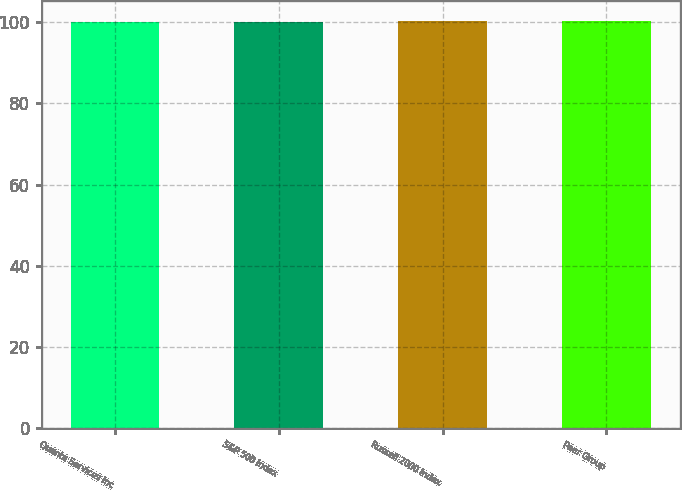Convert chart. <chart><loc_0><loc_0><loc_500><loc_500><bar_chart><fcel>Quanta Services Inc<fcel>S&P 500 Index<fcel>Russell 2000 Index<fcel>Peer Group<nl><fcel>100<fcel>100.1<fcel>100.2<fcel>100.3<nl></chart> 